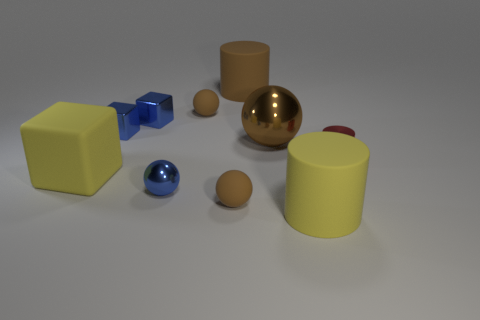What number of other things are there of the same material as the tiny blue sphere
Ensure brevity in your answer.  4. What number of blue things are either tiny cylinders or cubes?
Offer a very short reply. 2. Do the tiny brown rubber object in front of the yellow block and the rubber object right of the brown cylinder have the same shape?
Provide a short and direct response. No. There is a small metal cylinder; does it have the same color as the large metal sphere to the right of the matte block?
Provide a short and direct response. No. There is a cylinder in front of the tiny red metallic cylinder; is its color the same as the big metallic ball?
Make the answer very short. No. What number of things are either large purple metallic objects or spheres that are behind the red object?
Your answer should be very brief. 2. The large thing that is on the left side of the brown shiny ball and behind the small red cylinder is made of what material?
Your response must be concise. Rubber. There is a blue thing in front of the red thing; what is its material?
Ensure brevity in your answer.  Metal. There is a large block that is the same material as the brown cylinder; what color is it?
Make the answer very short. Yellow. Is the shape of the red thing the same as the big brown object in front of the large brown matte object?
Your answer should be compact. No. 